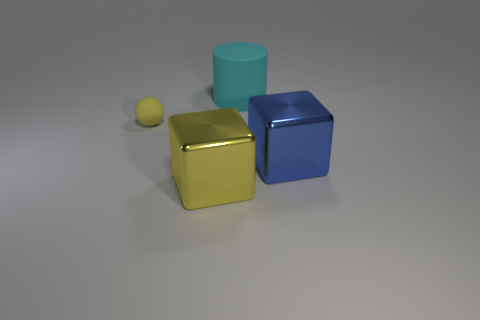What emotions or concepts could this arrangement of shapes represent? While inanimate objects like these don't inherently carry emotions, their arrangement and color scheme can evoke different interpretations. The clean geometry and primary colors could symbolize order, simplicity, and the fundamental building blocks. The composition might be interpreted as a visual metaphor for structure and balance, or even a minimalist approach to art and design. 